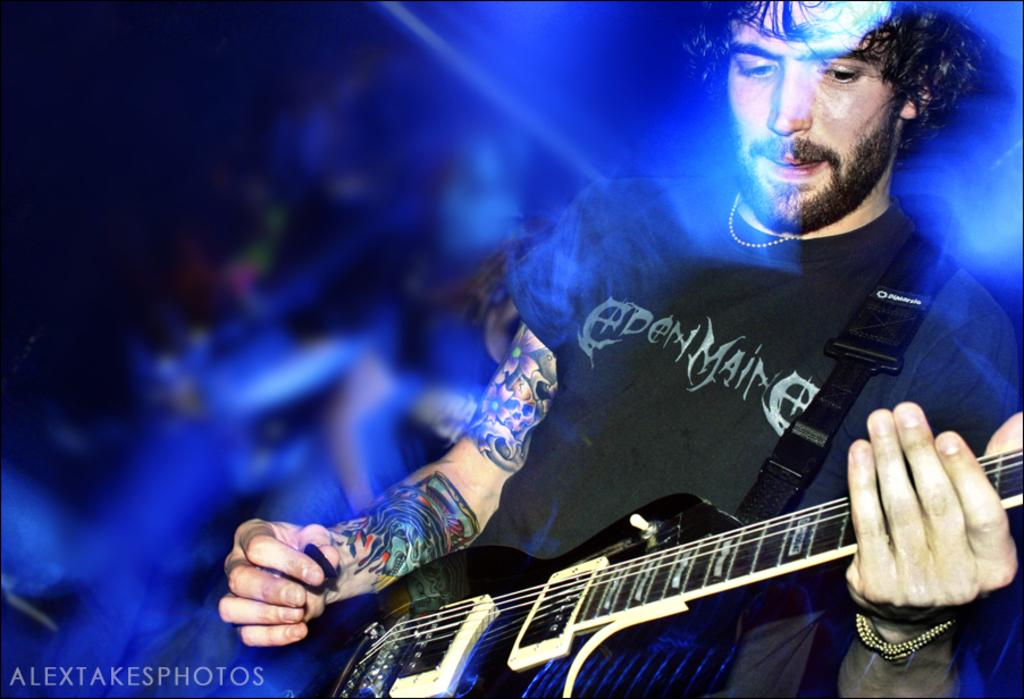What is the person in the image doing? The person is holding a guitar. What object is the person holding in their other hand? The person is holding a pick. Can you describe the background of the image? The background of the image is blurred. Is there any text present in the image? Yes, there is text at the bottom of the image. How many trees can be seen in the image? There are no trees visible in the image. What is the person doing to their ear in the image? The person is not doing anything to their ear in the image; they are holding a guitar and a pick. 